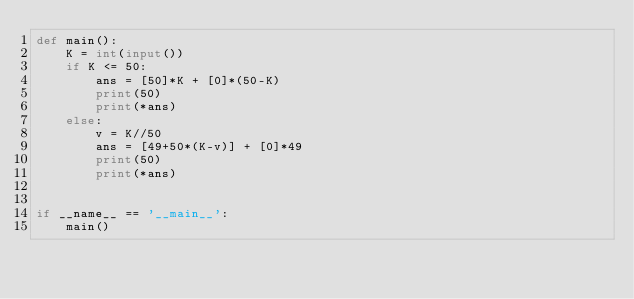Convert code to text. <code><loc_0><loc_0><loc_500><loc_500><_Python_>def main():
    K = int(input())
    if K <= 50:
        ans = [50]*K + [0]*(50-K)
        print(50)
        print(*ans)
    else:
        v = K//50
        ans = [49+50*(K-v)] + [0]*49
        print(50)
        print(*ans)


if __name__ == '__main__':
    main()
</code> 